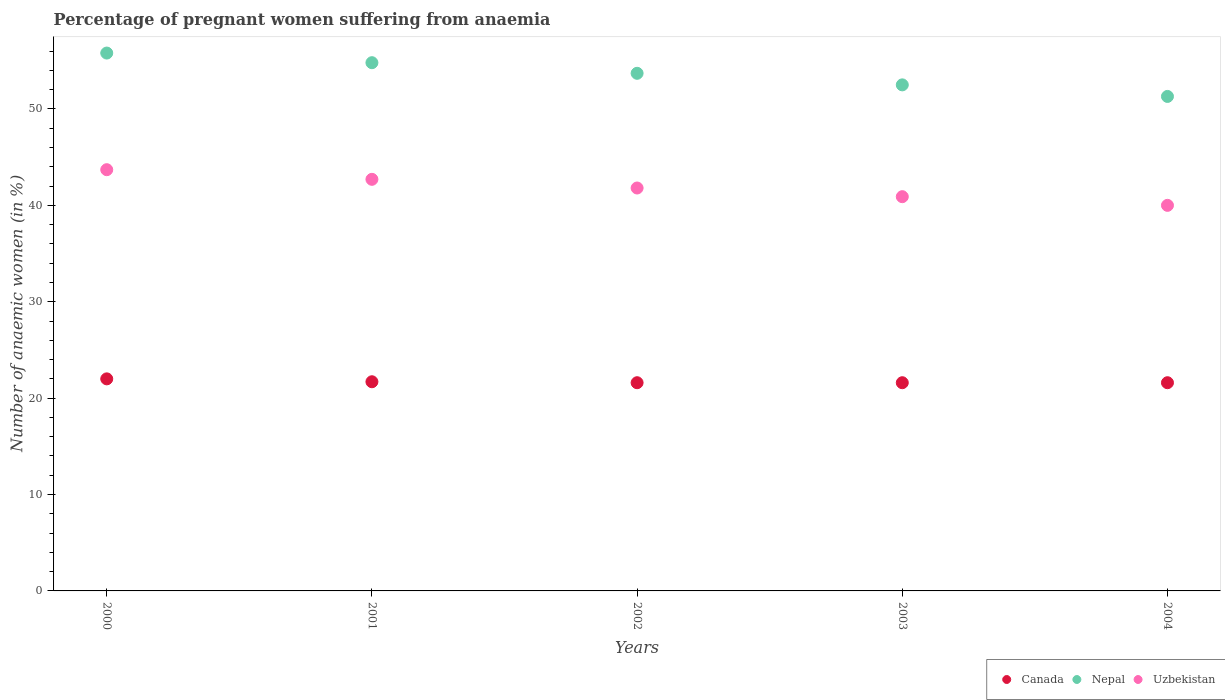How many different coloured dotlines are there?
Your answer should be compact. 3. Across all years, what is the maximum number of anaemic women in Nepal?
Keep it short and to the point. 55.8. Across all years, what is the minimum number of anaemic women in Nepal?
Provide a succinct answer. 51.3. In which year was the number of anaemic women in Uzbekistan minimum?
Ensure brevity in your answer.  2004. What is the total number of anaemic women in Uzbekistan in the graph?
Make the answer very short. 209.1. What is the difference between the number of anaemic women in Uzbekistan in 2000 and that in 2003?
Offer a terse response. 2.8. What is the difference between the number of anaemic women in Canada in 2001 and the number of anaemic women in Uzbekistan in 2000?
Give a very brief answer. -22. What is the average number of anaemic women in Uzbekistan per year?
Your answer should be very brief. 41.82. In the year 2003, what is the difference between the number of anaemic women in Nepal and number of anaemic women in Uzbekistan?
Make the answer very short. 11.6. In how many years, is the number of anaemic women in Uzbekistan greater than 2 %?
Your answer should be very brief. 5. What is the ratio of the number of anaemic women in Uzbekistan in 2000 to that in 2004?
Keep it short and to the point. 1.09. What is the difference between the highest and the second highest number of anaemic women in Nepal?
Ensure brevity in your answer.  1. What is the difference between the highest and the lowest number of anaemic women in Uzbekistan?
Offer a very short reply. 3.7. Does the number of anaemic women in Uzbekistan monotonically increase over the years?
Offer a terse response. No. How many dotlines are there?
Give a very brief answer. 3. How many years are there in the graph?
Offer a terse response. 5. Does the graph contain any zero values?
Provide a succinct answer. No. How many legend labels are there?
Make the answer very short. 3. How are the legend labels stacked?
Ensure brevity in your answer.  Horizontal. What is the title of the graph?
Make the answer very short. Percentage of pregnant women suffering from anaemia. Does "St. Kitts and Nevis" appear as one of the legend labels in the graph?
Ensure brevity in your answer.  No. What is the label or title of the Y-axis?
Offer a terse response. Number of anaemic women (in %). What is the Number of anaemic women (in %) of Nepal in 2000?
Offer a terse response. 55.8. What is the Number of anaemic women (in %) of Uzbekistan in 2000?
Offer a very short reply. 43.7. What is the Number of anaemic women (in %) of Canada in 2001?
Your response must be concise. 21.7. What is the Number of anaemic women (in %) in Nepal in 2001?
Offer a very short reply. 54.8. What is the Number of anaemic women (in %) in Uzbekistan in 2001?
Ensure brevity in your answer.  42.7. What is the Number of anaemic women (in %) in Canada in 2002?
Provide a short and direct response. 21.6. What is the Number of anaemic women (in %) of Nepal in 2002?
Provide a succinct answer. 53.7. What is the Number of anaemic women (in %) in Uzbekistan in 2002?
Offer a very short reply. 41.8. What is the Number of anaemic women (in %) in Canada in 2003?
Make the answer very short. 21.6. What is the Number of anaemic women (in %) in Nepal in 2003?
Your answer should be compact. 52.5. What is the Number of anaemic women (in %) of Uzbekistan in 2003?
Make the answer very short. 40.9. What is the Number of anaemic women (in %) in Canada in 2004?
Your answer should be very brief. 21.6. What is the Number of anaemic women (in %) of Nepal in 2004?
Your answer should be very brief. 51.3. What is the Number of anaemic women (in %) in Uzbekistan in 2004?
Offer a terse response. 40. Across all years, what is the maximum Number of anaemic women (in %) of Nepal?
Your answer should be compact. 55.8. Across all years, what is the maximum Number of anaemic women (in %) in Uzbekistan?
Provide a short and direct response. 43.7. Across all years, what is the minimum Number of anaemic women (in %) of Canada?
Keep it short and to the point. 21.6. Across all years, what is the minimum Number of anaemic women (in %) of Nepal?
Your answer should be compact. 51.3. Across all years, what is the minimum Number of anaemic women (in %) of Uzbekistan?
Your answer should be very brief. 40. What is the total Number of anaemic women (in %) in Canada in the graph?
Your answer should be compact. 108.5. What is the total Number of anaemic women (in %) of Nepal in the graph?
Provide a short and direct response. 268.1. What is the total Number of anaemic women (in %) in Uzbekistan in the graph?
Make the answer very short. 209.1. What is the difference between the Number of anaemic women (in %) of Canada in 2000 and that in 2001?
Ensure brevity in your answer.  0.3. What is the difference between the Number of anaemic women (in %) in Uzbekistan in 2000 and that in 2001?
Provide a short and direct response. 1. What is the difference between the Number of anaemic women (in %) of Canada in 2000 and that in 2002?
Offer a very short reply. 0.4. What is the difference between the Number of anaemic women (in %) of Nepal in 2000 and that in 2002?
Keep it short and to the point. 2.1. What is the difference between the Number of anaemic women (in %) of Uzbekistan in 2000 and that in 2002?
Make the answer very short. 1.9. What is the difference between the Number of anaemic women (in %) in Nepal in 2000 and that in 2003?
Your response must be concise. 3.3. What is the difference between the Number of anaemic women (in %) of Uzbekistan in 2000 and that in 2003?
Keep it short and to the point. 2.8. What is the difference between the Number of anaemic women (in %) of Canada in 2000 and that in 2004?
Your response must be concise. 0.4. What is the difference between the Number of anaemic women (in %) of Uzbekistan in 2000 and that in 2004?
Your response must be concise. 3.7. What is the difference between the Number of anaemic women (in %) in Canada in 2001 and that in 2002?
Your response must be concise. 0.1. What is the difference between the Number of anaemic women (in %) of Uzbekistan in 2001 and that in 2002?
Your answer should be very brief. 0.9. What is the difference between the Number of anaemic women (in %) of Uzbekistan in 2001 and that in 2003?
Offer a terse response. 1.8. What is the difference between the Number of anaemic women (in %) in Canada in 2001 and that in 2004?
Make the answer very short. 0.1. What is the difference between the Number of anaemic women (in %) in Uzbekistan in 2001 and that in 2004?
Offer a terse response. 2.7. What is the difference between the Number of anaemic women (in %) of Uzbekistan in 2002 and that in 2003?
Your response must be concise. 0.9. What is the difference between the Number of anaemic women (in %) in Uzbekistan in 2002 and that in 2004?
Offer a terse response. 1.8. What is the difference between the Number of anaemic women (in %) in Canada in 2003 and that in 2004?
Provide a succinct answer. 0. What is the difference between the Number of anaemic women (in %) in Nepal in 2003 and that in 2004?
Offer a very short reply. 1.2. What is the difference between the Number of anaemic women (in %) of Canada in 2000 and the Number of anaemic women (in %) of Nepal in 2001?
Your answer should be very brief. -32.8. What is the difference between the Number of anaemic women (in %) in Canada in 2000 and the Number of anaemic women (in %) in Uzbekistan in 2001?
Keep it short and to the point. -20.7. What is the difference between the Number of anaemic women (in %) in Nepal in 2000 and the Number of anaemic women (in %) in Uzbekistan in 2001?
Offer a terse response. 13.1. What is the difference between the Number of anaemic women (in %) in Canada in 2000 and the Number of anaemic women (in %) in Nepal in 2002?
Ensure brevity in your answer.  -31.7. What is the difference between the Number of anaemic women (in %) of Canada in 2000 and the Number of anaemic women (in %) of Uzbekistan in 2002?
Provide a succinct answer. -19.8. What is the difference between the Number of anaemic women (in %) in Nepal in 2000 and the Number of anaemic women (in %) in Uzbekistan in 2002?
Your answer should be very brief. 14. What is the difference between the Number of anaemic women (in %) in Canada in 2000 and the Number of anaemic women (in %) in Nepal in 2003?
Give a very brief answer. -30.5. What is the difference between the Number of anaemic women (in %) in Canada in 2000 and the Number of anaemic women (in %) in Uzbekistan in 2003?
Your response must be concise. -18.9. What is the difference between the Number of anaemic women (in %) in Nepal in 2000 and the Number of anaemic women (in %) in Uzbekistan in 2003?
Provide a short and direct response. 14.9. What is the difference between the Number of anaemic women (in %) of Canada in 2000 and the Number of anaemic women (in %) of Nepal in 2004?
Offer a terse response. -29.3. What is the difference between the Number of anaemic women (in %) of Canada in 2000 and the Number of anaemic women (in %) of Uzbekistan in 2004?
Your answer should be compact. -18. What is the difference between the Number of anaemic women (in %) in Nepal in 2000 and the Number of anaemic women (in %) in Uzbekistan in 2004?
Provide a succinct answer. 15.8. What is the difference between the Number of anaemic women (in %) of Canada in 2001 and the Number of anaemic women (in %) of Nepal in 2002?
Provide a short and direct response. -32. What is the difference between the Number of anaemic women (in %) in Canada in 2001 and the Number of anaemic women (in %) in Uzbekistan in 2002?
Your response must be concise. -20.1. What is the difference between the Number of anaemic women (in %) of Canada in 2001 and the Number of anaemic women (in %) of Nepal in 2003?
Offer a terse response. -30.8. What is the difference between the Number of anaemic women (in %) in Canada in 2001 and the Number of anaemic women (in %) in Uzbekistan in 2003?
Ensure brevity in your answer.  -19.2. What is the difference between the Number of anaemic women (in %) in Nepal in 2001 and the Number of anaemic women (in %) in Uzbekistan in 2003?
Offer a terse response. 13.9. What is the difference between the Number of anaemic women (in %) in Canada in 2001 and the Number of anaemic women (in %) in Nepal in 2004?
Your answer should be compact. -29.6. What is the difference between the Number of anaemic women (in %) of Canada in 2001 and the Number of anaemic women (in %) of Uzbekistan in 2004?
Provide a succinct answer. -18.3. What is the difference between the Number of anaemic women (in %) in Nepal in 2001 and the Number of anaemic women (in %) in Uzbekistan in 2004?
Your answer should be very brief. 14.8. What is the difference between the Number of anaemic women (in %) in Canada in 2002 and the Number of anaemic women (in %) in Nepal in 2003?
Provide a short and direct response. -30.9. What is the difference between the Number of anaemic women (in %) in Canada in 2002 and the Number of anaemic women (in %) in Uzbekistan in 2003?
Keep it short and to the point. -19.3. What is the difference between the Number of anaemic women (in %) in Canada in 2002 and the Number of anaemic women (in %) in Nepal in 2004?
Offer a very short reply. -29.7. What is the difference between the Number of anaemic women (in %) of Canada in 2002 and the Number of anaemic women (in %) of Uzbekistan in 2004?
Your answer should be compact. -18.4. What is the difference between the Number of anaemic women (in %) in Canada in 2003 and the Number of anaemic women (in %) in Nepal in 2004?
Your answer should be compact. -29.7. What is the difference between the Number of anaemic women (in %) of Canada in 2003 and the Number of anaemic women (in %) of Uzbekistan in 2004?
Give a very brief answer. -18.4. What is the average Number of anaemic women (in %) in Canada per year?
Your answer should be compact. 21.7. What is the average Number of anaemic women (in %) in Nepal per year?
Ensure brevity in your answer.  53.62. What is the average Number of anaemic women (in %) in Uzbekistan per year?
Give a very brief answer. 41.82. In the year 2000, what is the difference between the Number of anaemic women (in %) in Canada and Number of anaemic women (in %) in Nepal?
Provide a succinct answer. -33.8. In the year 2000, what is the difference between the Number of anaemic women (in %) in Canada and Number of anaemic women (in %) in Uzbekistan?
Ensure brevity in your answer.  -21.7. In the year 2000, what is the difference between the Number of anaemic women (in %) in Nepal and Number of anaemic women (in %) in Uzbekistan?
Make the answer very short. 12.1. In the year 2001, what is the difference between the Number of anaemic women (in %) in Canada and Number of anaemic women (in %) in Nepal?
Keep it short and to the point. -33.1. In the year 2002, what is the difference between the Number of anaemic women (in %) of Canada and Number of anaemic women (in %) of Nepal?
Give a very brief answer. -32.1. In the year 2002, what is the difference between the Number of anaemic women (in %) in Canada and Number of anaemic women (in %) in Uzbekistan?
Provide a succinct answer. -20.2. In the year 2003, what is the difference between the Number of anaemic women (in %) of Canada and Number of anaemic women (in %) of Nepal?
Keep it short and to the point. -30.9. In the year 2003, what is the difference between the Number of anaemic women (in %) of Canada and Number of anaemic women (in %) of Uzbekistan?
Your response must be concise. -19.3. In the year 2004, what is the difference between the Number of anaemic women (in %) in Canada and Number of anaemic women (in %) in Nepal?
Offer a very short reply. -29.7. In the year 2004, what is the difference between the Number of anaemic women (in %) in Canada and Number of anaemic women (in %) in Uzbekistan?
Your answer should be very brief. -18.4. In the year 2004, what is the difference between the Number of anaemic women (in %) in Nepal and Number of anaemic women (in %) in Uzbekistan?
Offer a very short reply. 11.3. What is the ratio of the Number of anaemic women (in %) of Canada in 2000 to that in 2001?
Keep it short and to the point. 1.01. What is the ratio of the Number of anaemic women (in %) of Nepal in 2000 to that in 2001?
Your answer should be very brief. 1.02. What is the ratio of the Number of anaemic women (in %) of Uzbekistan in 2000 to that in 2001?
Your response must be concise. 1.02. What is the ratio of the Number of anaemic women (in %) of Canada in 2000 to that in 2002?
Offer a terse response. 1.02. What is the ratio of the Number of anaemic women (in %) of Nepal in 2000 to that in 2002?
Provide a succinct answer. 1.04. What is the ratio of the Number of anaemic women (in %) of Uzbekistan in 2000 to that in 2002?
Ensure brevity in your answer.  1.05. What is the ratio of the Number of anaemic women (in %) in Canada in 2000 to that in 2003?
Provide a succinct answer. 1.02. What is the ratio of the Number of anaemic women (in %) of Nepal in 2000 to that in 2003?
Provide a succinct answer. 1.06. What is the ratio of the Number of anaemic women (in %) of Uzbekistan in 2000 to that in 2003?
Provide a succinct answer. 1.07. What is the ratio of the Number of anaemic women (in %) of Canada in 2000 to that in 2004?
Ensure brevity in your answer.  1.02. What is the ratio of the Number of anaemic women (in %) in Nepal in 2000 to that in 2004?
Offer a very short reply. 1.09. What is the ratio of the Number of anaemic women (in %) of Uzbekistan in 2000 to that in 2004?
Keep it short and to the point. 1.09. What is the ratio of the Number of anaemic women (in %) of Canada in 2001 to that in 2002?
Give a very brief answer. 1. What is the ratio of the Number of anaemic women (in %) of Nepal in 2001 to that in 2002?
Your response must be concise. 1.02. What is the ratio of the Number of anaemic women (in %) in Uzbekistan in 2001 to that in 2002?
Make the answer very short. 1.02. What is the ratio of the Number of anaemic women (in %) of Nepal in 2001 to that in 2003?
Provide a succinct answer. 1.04. What is the ratio of the Number of anaemic women (in %) in Uzbekistan in 2001 to that in 2003?
Offer a very short reply. 1.04. What is the ratio of the Number of anaemic women (in %) in Nepal in 2001 to that in 2004?
Provide a short and direct response. 1.07. What is the ratio of the Number of anaemic women (in %) of Uzbekistan in 2001 to that in 2004?
Your answer should be compact. 1.07. What is the ratio of the Number of anaemic women (in %) of Canada in 2002 to that in 2003?
Your answer should be very brief. 1. What is the ratio of the Number of anaemic women (in %) in Nepal in 2002 to that in 2003?
Your answer should be very brief. 1.02. What is the ratio of the Number of anaemic women (in %) in Uzbekistan in 2002 to that in 2003?
Offer a terse response. 1.02. What is the ratio of the Number of anaemic women (in %) in Nepal in 2002 to that in 2004?
Your response must be concise. 1.05. What is the ratio of the Number of anaemic women (in %) in Uzbekistan in 2002 to that in 2004?
Offer a very short reply. 1.04. What is the ratio of the Number of anaemic women (in %) of Canada in 2003 to that in 2004?
Your answer should be compact. 1. What is the ratio of the Number of anaemic women (in %) of Nepal in 2003 to that in 2004?
Your answer should be compact. 1.02. What is the ratio of the Number of anaemic women (in %) in Uzbekistan in 2003 to that in 2004?
Provide a succinct answer. 1.02. What is the difference between the highest and the second highest Number of anaemic women (in %) in Nepal?
Give a very brief answer. 1. What is the difference between the highest and the second highest Number of anaemic women (in %) of Uzbekistan?
Give a very brief answer. 1. What is the difference between the highest and the lowest Number of anaemic women (in %) of Nepal?
Your answer should be compact. 4.5. 